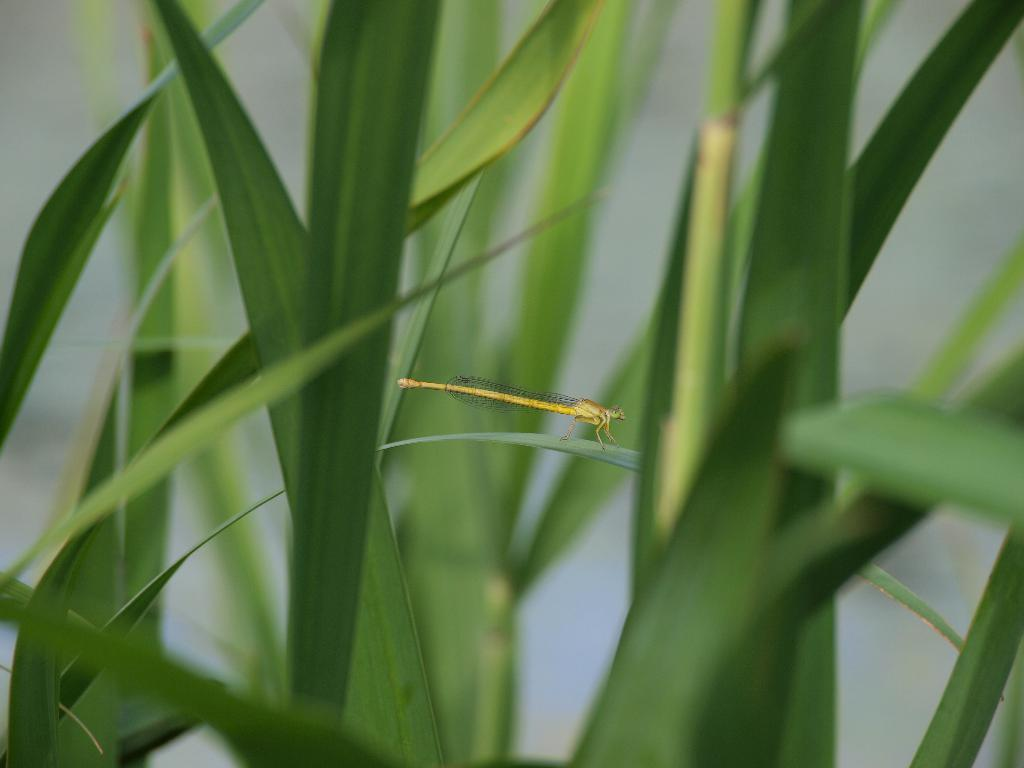What type of creature can be seen in the image? There is an insect in the image. What color is the insect? The insect is yellow in color. Where is the insect located in the image? The insect is on a leaf. What type of vegetation is present in the image? There are plants in the image, and they are green in color. What color is the background of the image? The background of the image is white. How many squares can be seen in the wilderness depicted in the image? There are no squares or wilderness present in the image; it features an insect on a leaf with green plants and a white background. 